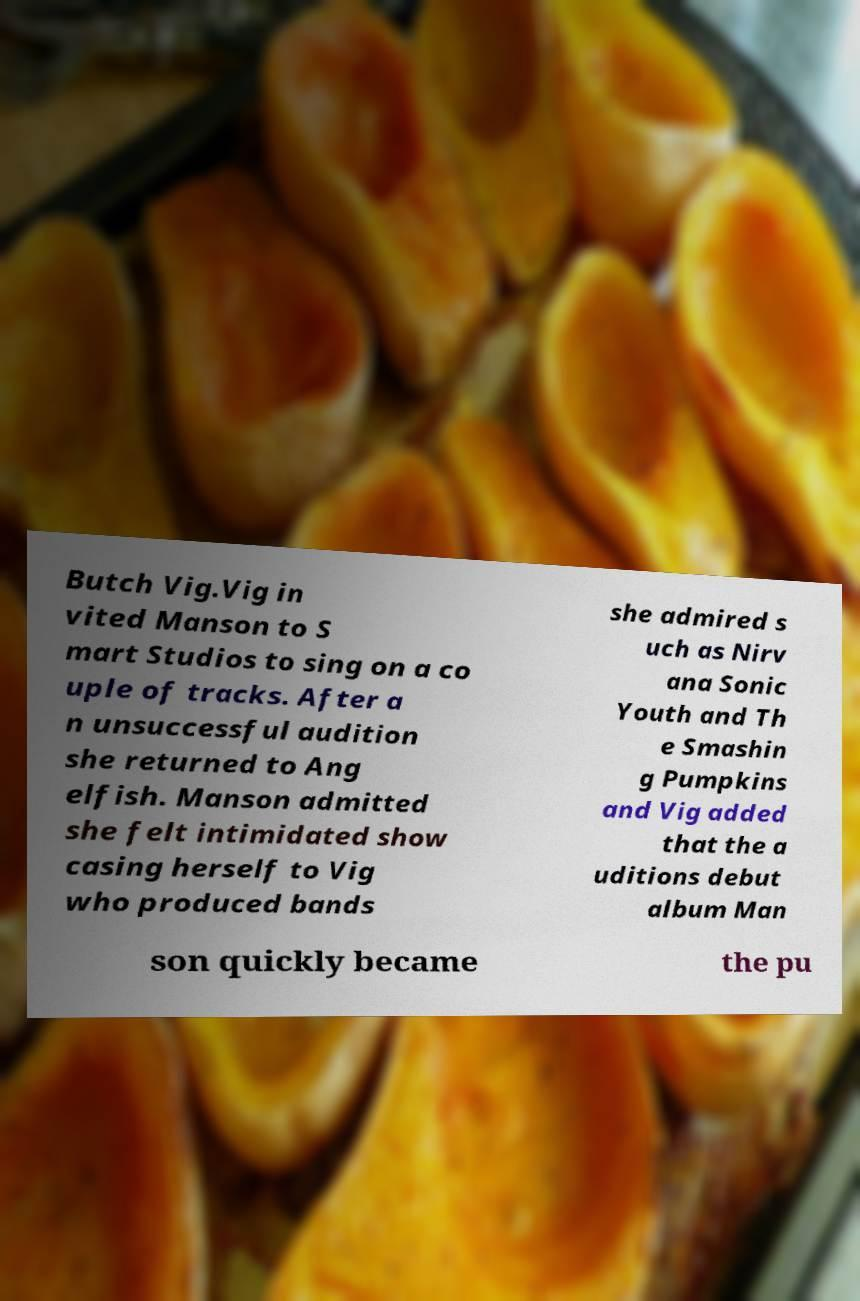Can you accurately transcribe the text from the provided image for me? Butch Vig.Vig in vited Manson to S mart Studios to sing on a co uple of tracks. After a n unsuccessful audition she returned to Ang elfish. Manson admitted she felt intimidated show casing herself to Vig who produced bands she admired s uch as Nirv ana Sonic Youth and Th e Smashin g Pumpkins and Vig added that the a uditions debut album Man son quickly became the pu 